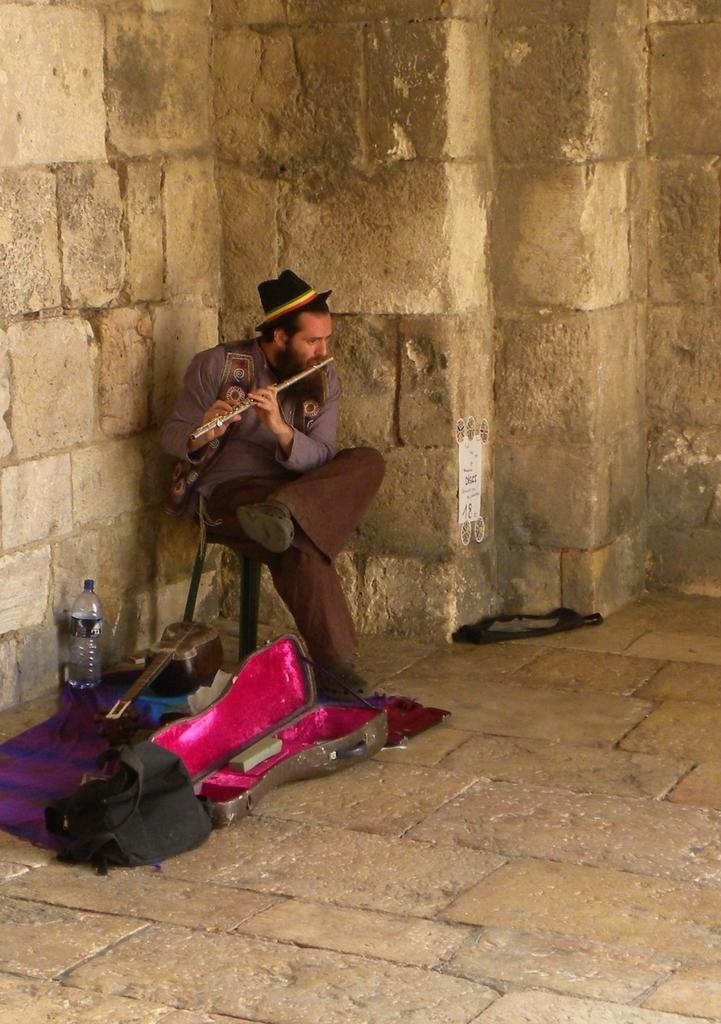What is the person in the image doing? The person is sitting on a chair and playing a flute. What is on the floor near the person? There is a musical instrument cloth and a bottle on the floor. What type of goose can be seen wearing a coat in the image? There is no goose or coat present in the image. What kind of beast is playing the flute in the image? The person playing the flute in the image is not described as a beast; they are simply a person. 